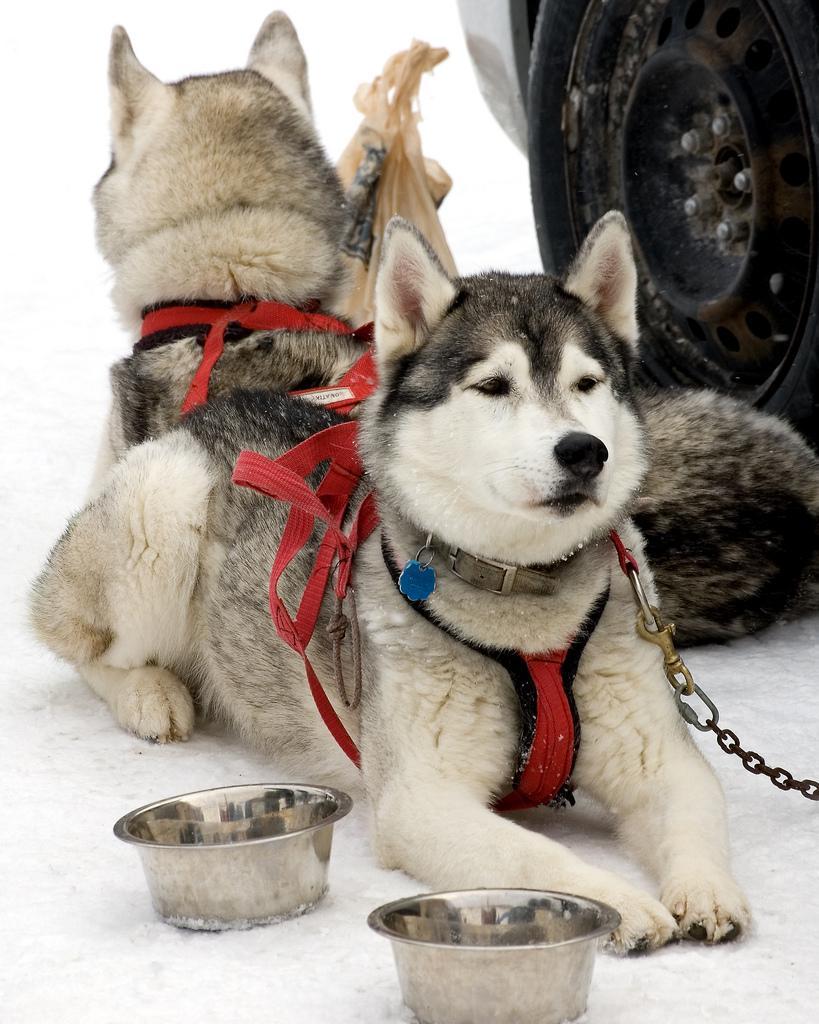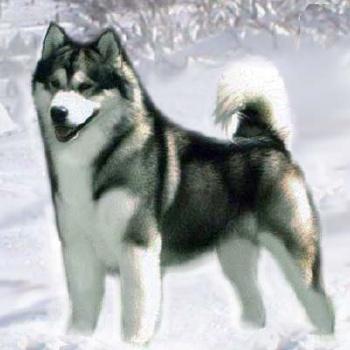The first image is the image on the left, the second image is the image on the right. Considering the images on both sides, is "One image features a dog sitting upright to the right of a dog in a reclining pose, and the other image includes a dog with snow on its fur." valid? Answer yes or no. No. The first image is the image on the left, the second image is the image on the right. Assess this claim about the two images: "One of the images contains one Husky dog and the other image contains two Husky dogs.". Correct or not? Answer yes or no. Yes. 